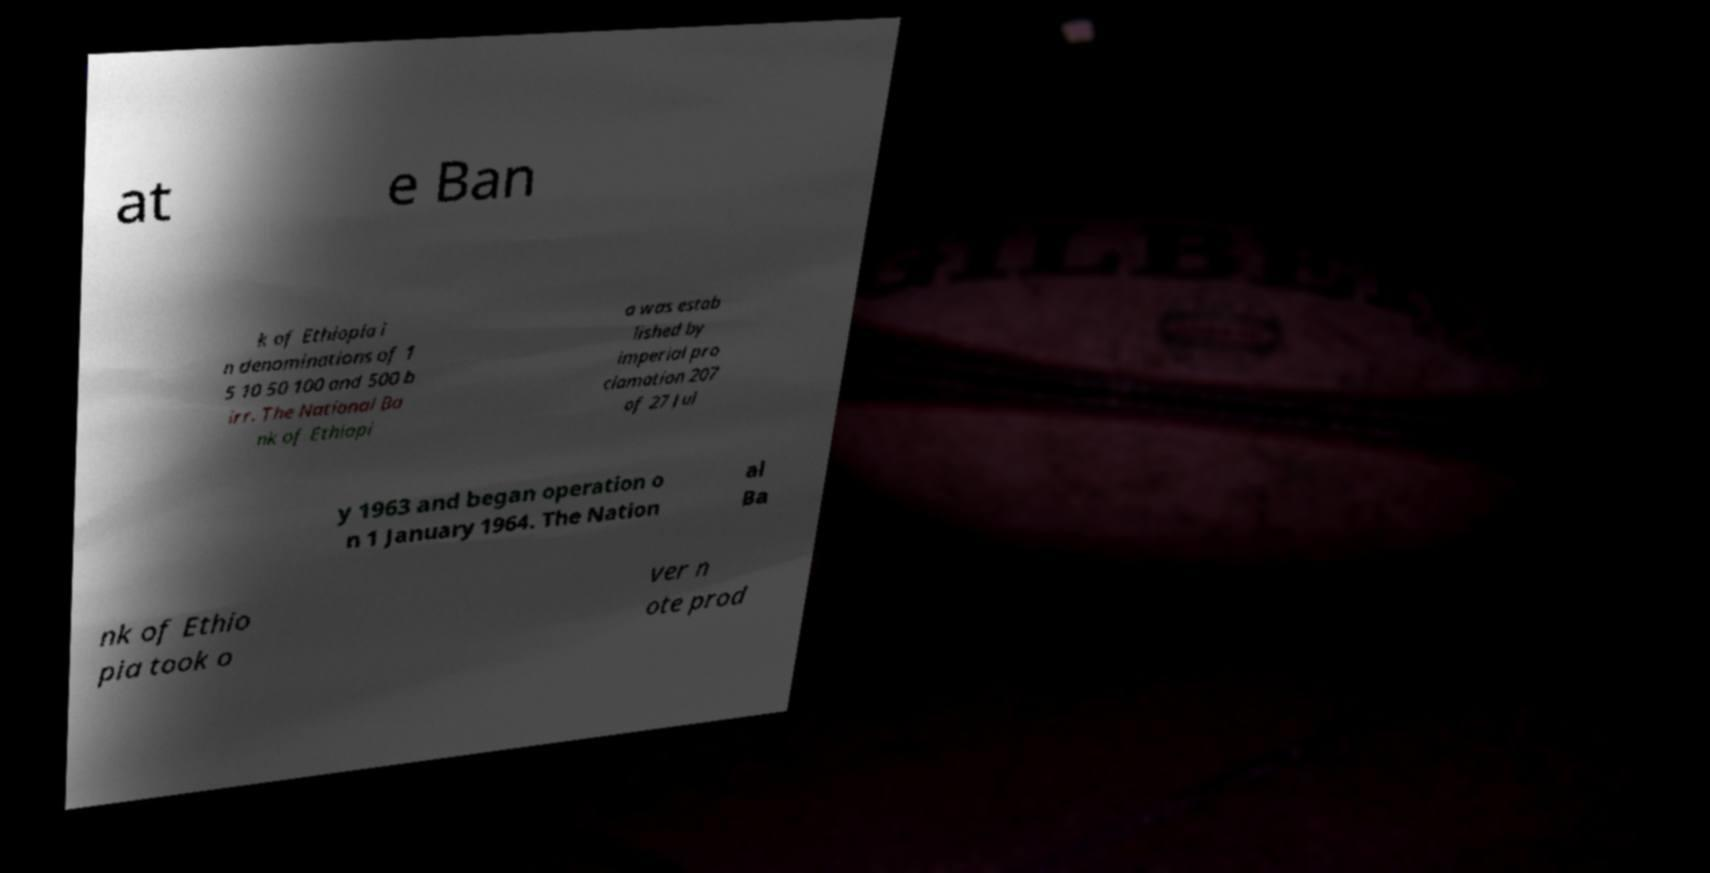Can you accurately transcribe the text from the provided image for me? at e Ban k of Ethiopia i n denominations of 1 5 10 50 100 and 500 b irr. The National Ba nk of Ethiopi a was estab lished by imperial pro clamation 207 of 27 Jul y 1963 and began operation o n 1 January 1964. The Nation al Ba nk of Ethio pia took o ver n ote prod 